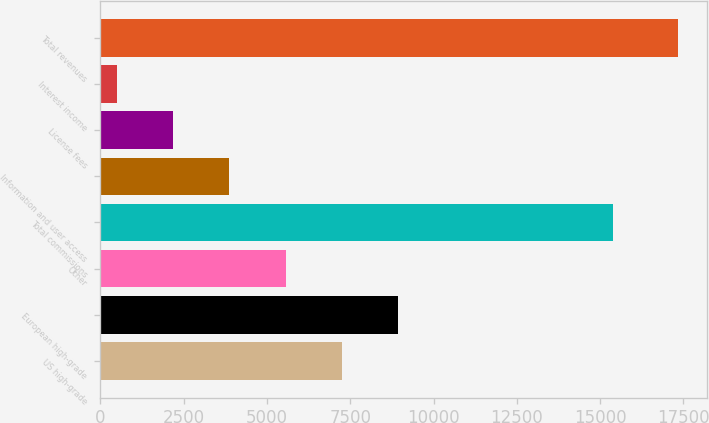<chart> <loc_0><loc_0><loc_500><loc_500><bar_chart><fcel>US high-grade<fcel>European high-grade<fcel>Other<fcel>Total commissions<fcel>Information and user access<fcel>License fees<fcel>Interest income<fcel>Total revenues<nl><fcel>7241.4<fcel>8924<fcel>5558.8<fcel>15372<fcel>3876.2<fcel>2193.6<fcel>511<fcel>17337<nl></chart> 